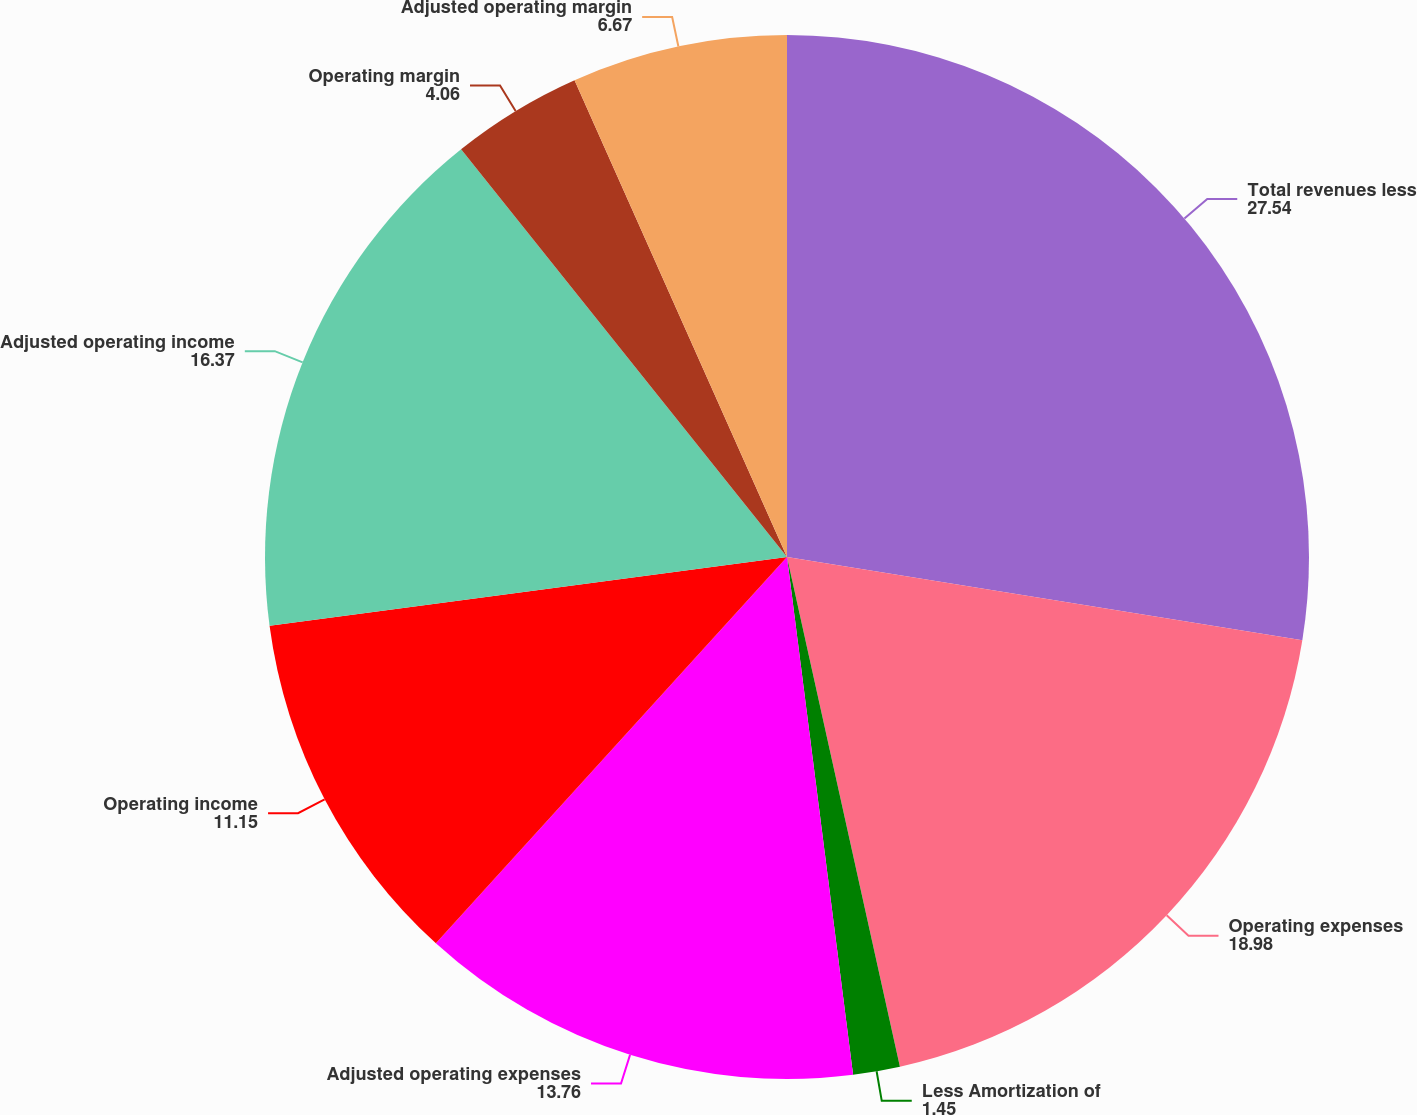Convert chart. <chart><loc_0><loc_0><loc_500><loc_500><pie_chart><fcel>Total revenues less<fcel>Operating expenses<fcel>Less Amortization of<fcel>Adjusted operating expenses<fcel>Operating income<fcel>Adjusted operating income<fcel>Operating margin<fcel>Adjusted operating margin<nl><fcel>27.54%<fcel>18.98%<fcel>1.45%<fcel>13.76%<fcel>11.15%<fcel>16.37%<fcel>4.06%<fcel>6.67%<nl></chart> 